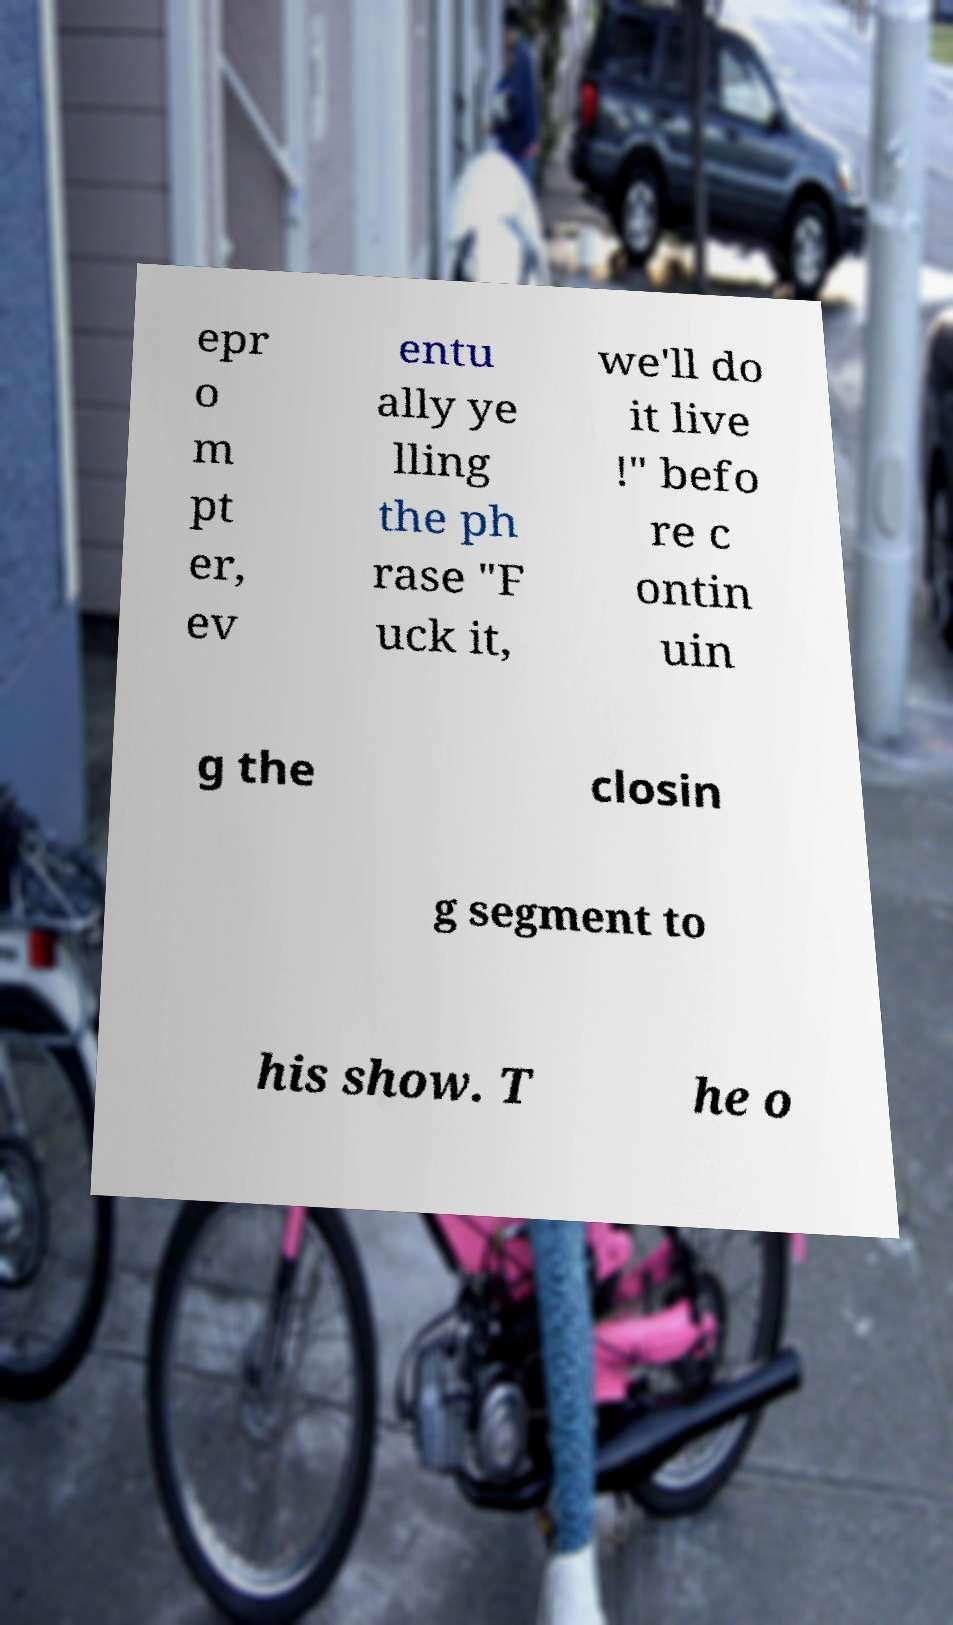Can you accurately transcribe the text from the provided image for me? epr o m pt er, ev entu ally ye lling the ph rase "F uck it, we'll do it live !" befo re c ontin uin g the closin g segment to his show. T he o 